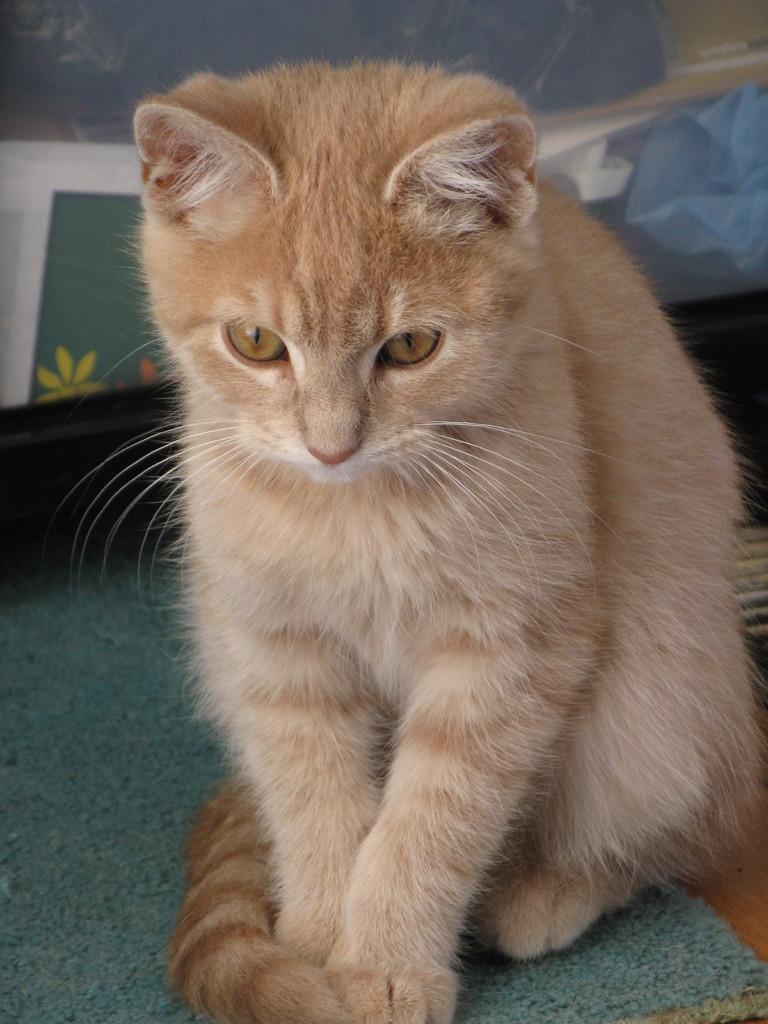In one or two sentences, can you explain what this image depicts? In this image we can see the cat on the cloth and at the back it looks like a cover with a design. 